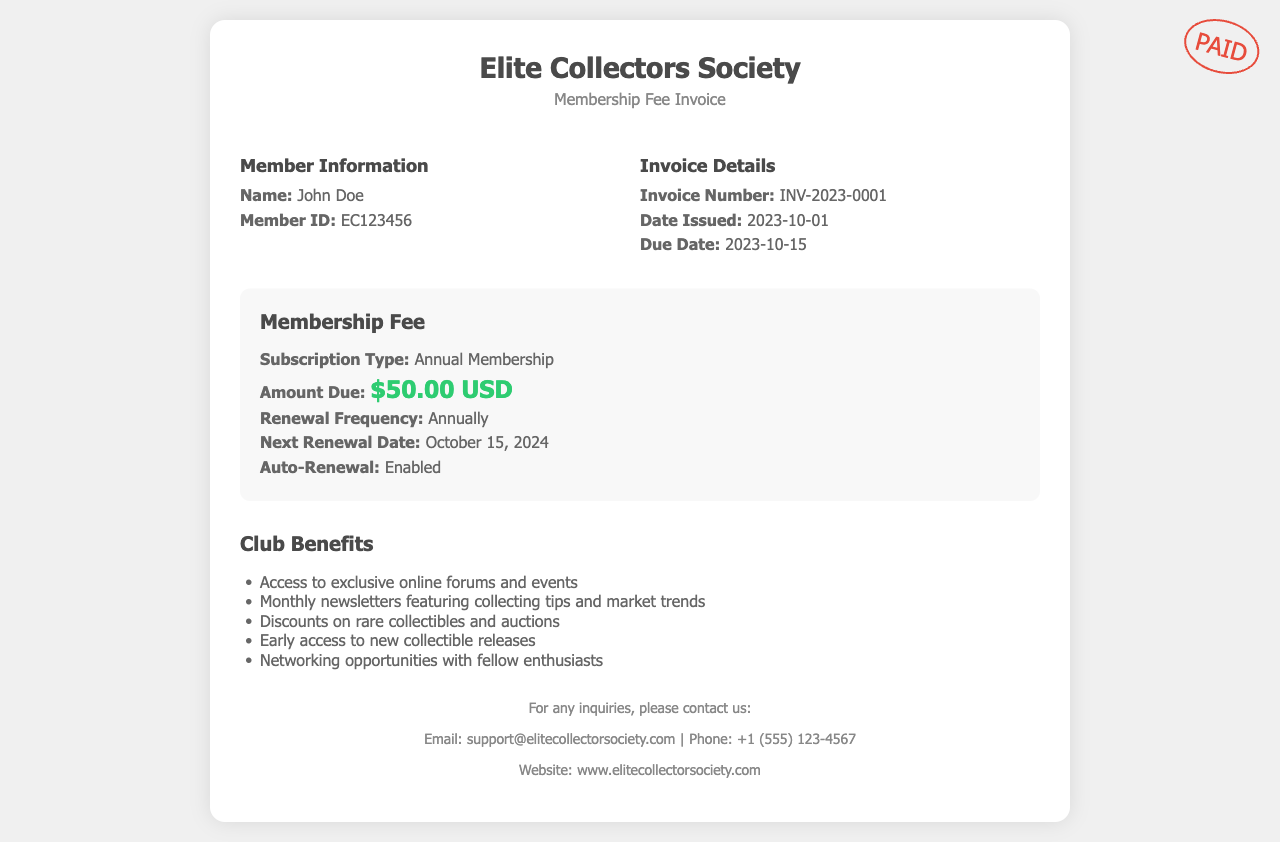what is the member's name? The member's name is listed in the Member Information section of the document as John Doe.
Answer: John Doe what is the membership fee amount due? The amount due is specified in the Membership Fee section of the document as $50.00 USD.
Answer: $50.00 USD what is the membership renewal frequency? The renewal frequency can be found in the Membership Fee section and reads "Annually".
Answer: Annually when is the next renewal date? The next renewal date is provided in the Membership Fee section of the document as October 15, 2024.
Answer: October 15, 2024 what is the invoice number? The invoice number is indicated in the Invoice Details section as INV-2023-0001.
Answer: INV-2023-0001 what are two benefits of club membership? The benefits of club membership are listed in the Club Benefits section, including "Access to exclusive online forums and events" and "Monthly newsletters featuring collecting tips and market trends".
Answer: Access to exclusive online forums and events, Monthly newsletters featuring collecting tips and market trends is auto-renewal enabled? The Membership Fee section clearly states that auto-renewal is enabled.
Answer: Enabled what is the due date for the membership fee? The due date is highlighted in the Invoice Details section as 2023-10-15.
Answer: 2023-10-15 